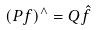<formula> <loc_0><loc_0><loc_500><loc_500>( P f ) ^ { \wedge } = Q \hat { f }</formula> 